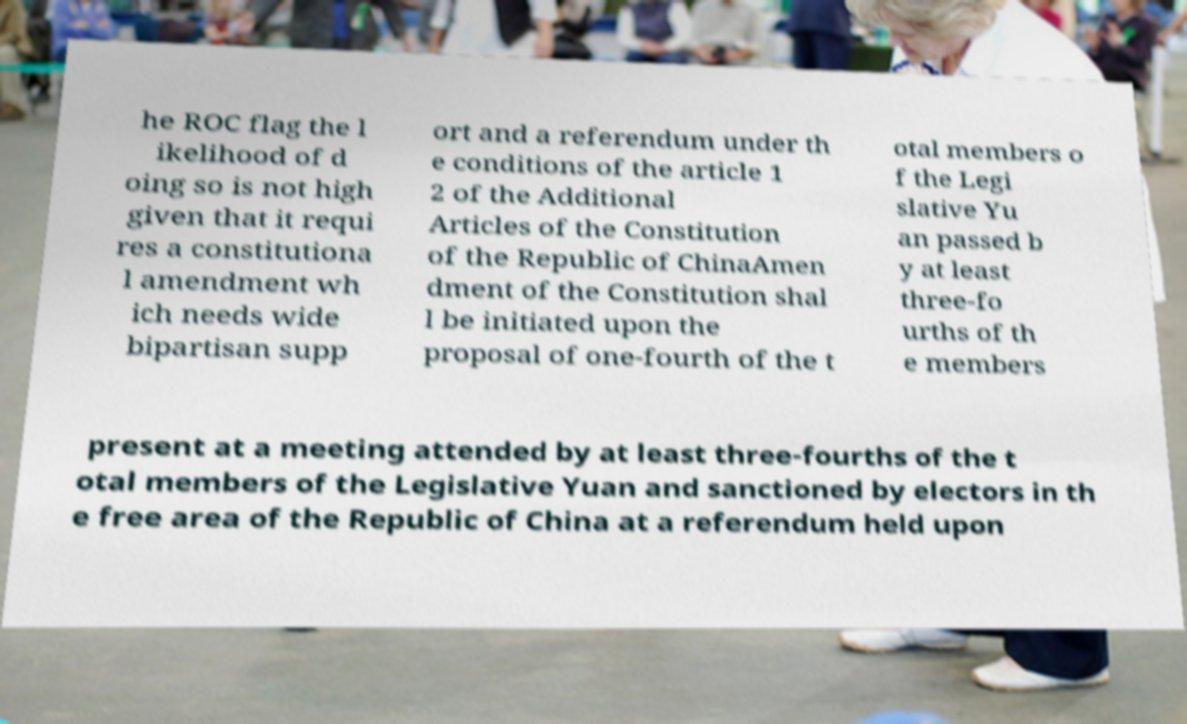There's text embedded in this image that I need extracted. Can you transcribe it verbatim? he ROC flag the l ikelihood of d oing so is not high given that it requi res a constitutiona l amendment wh ich needs wide bipartisan supp ort and a referendum under th e conditions of the article 1 2 of the Additional Articles of the Constitution of the Republic of ChinaAmen dment of the Constitution shal l be initiated upon the proposal of one-fourth of the t otal members o f the Legi slative Yu an passed b y at least three-fo urths of th e members present at a meeting attended by at least three-fourths of the t otal members of the Legislative Yuan and sanctioned by electors in th e free area of the Republic of China at a referendum held upon 